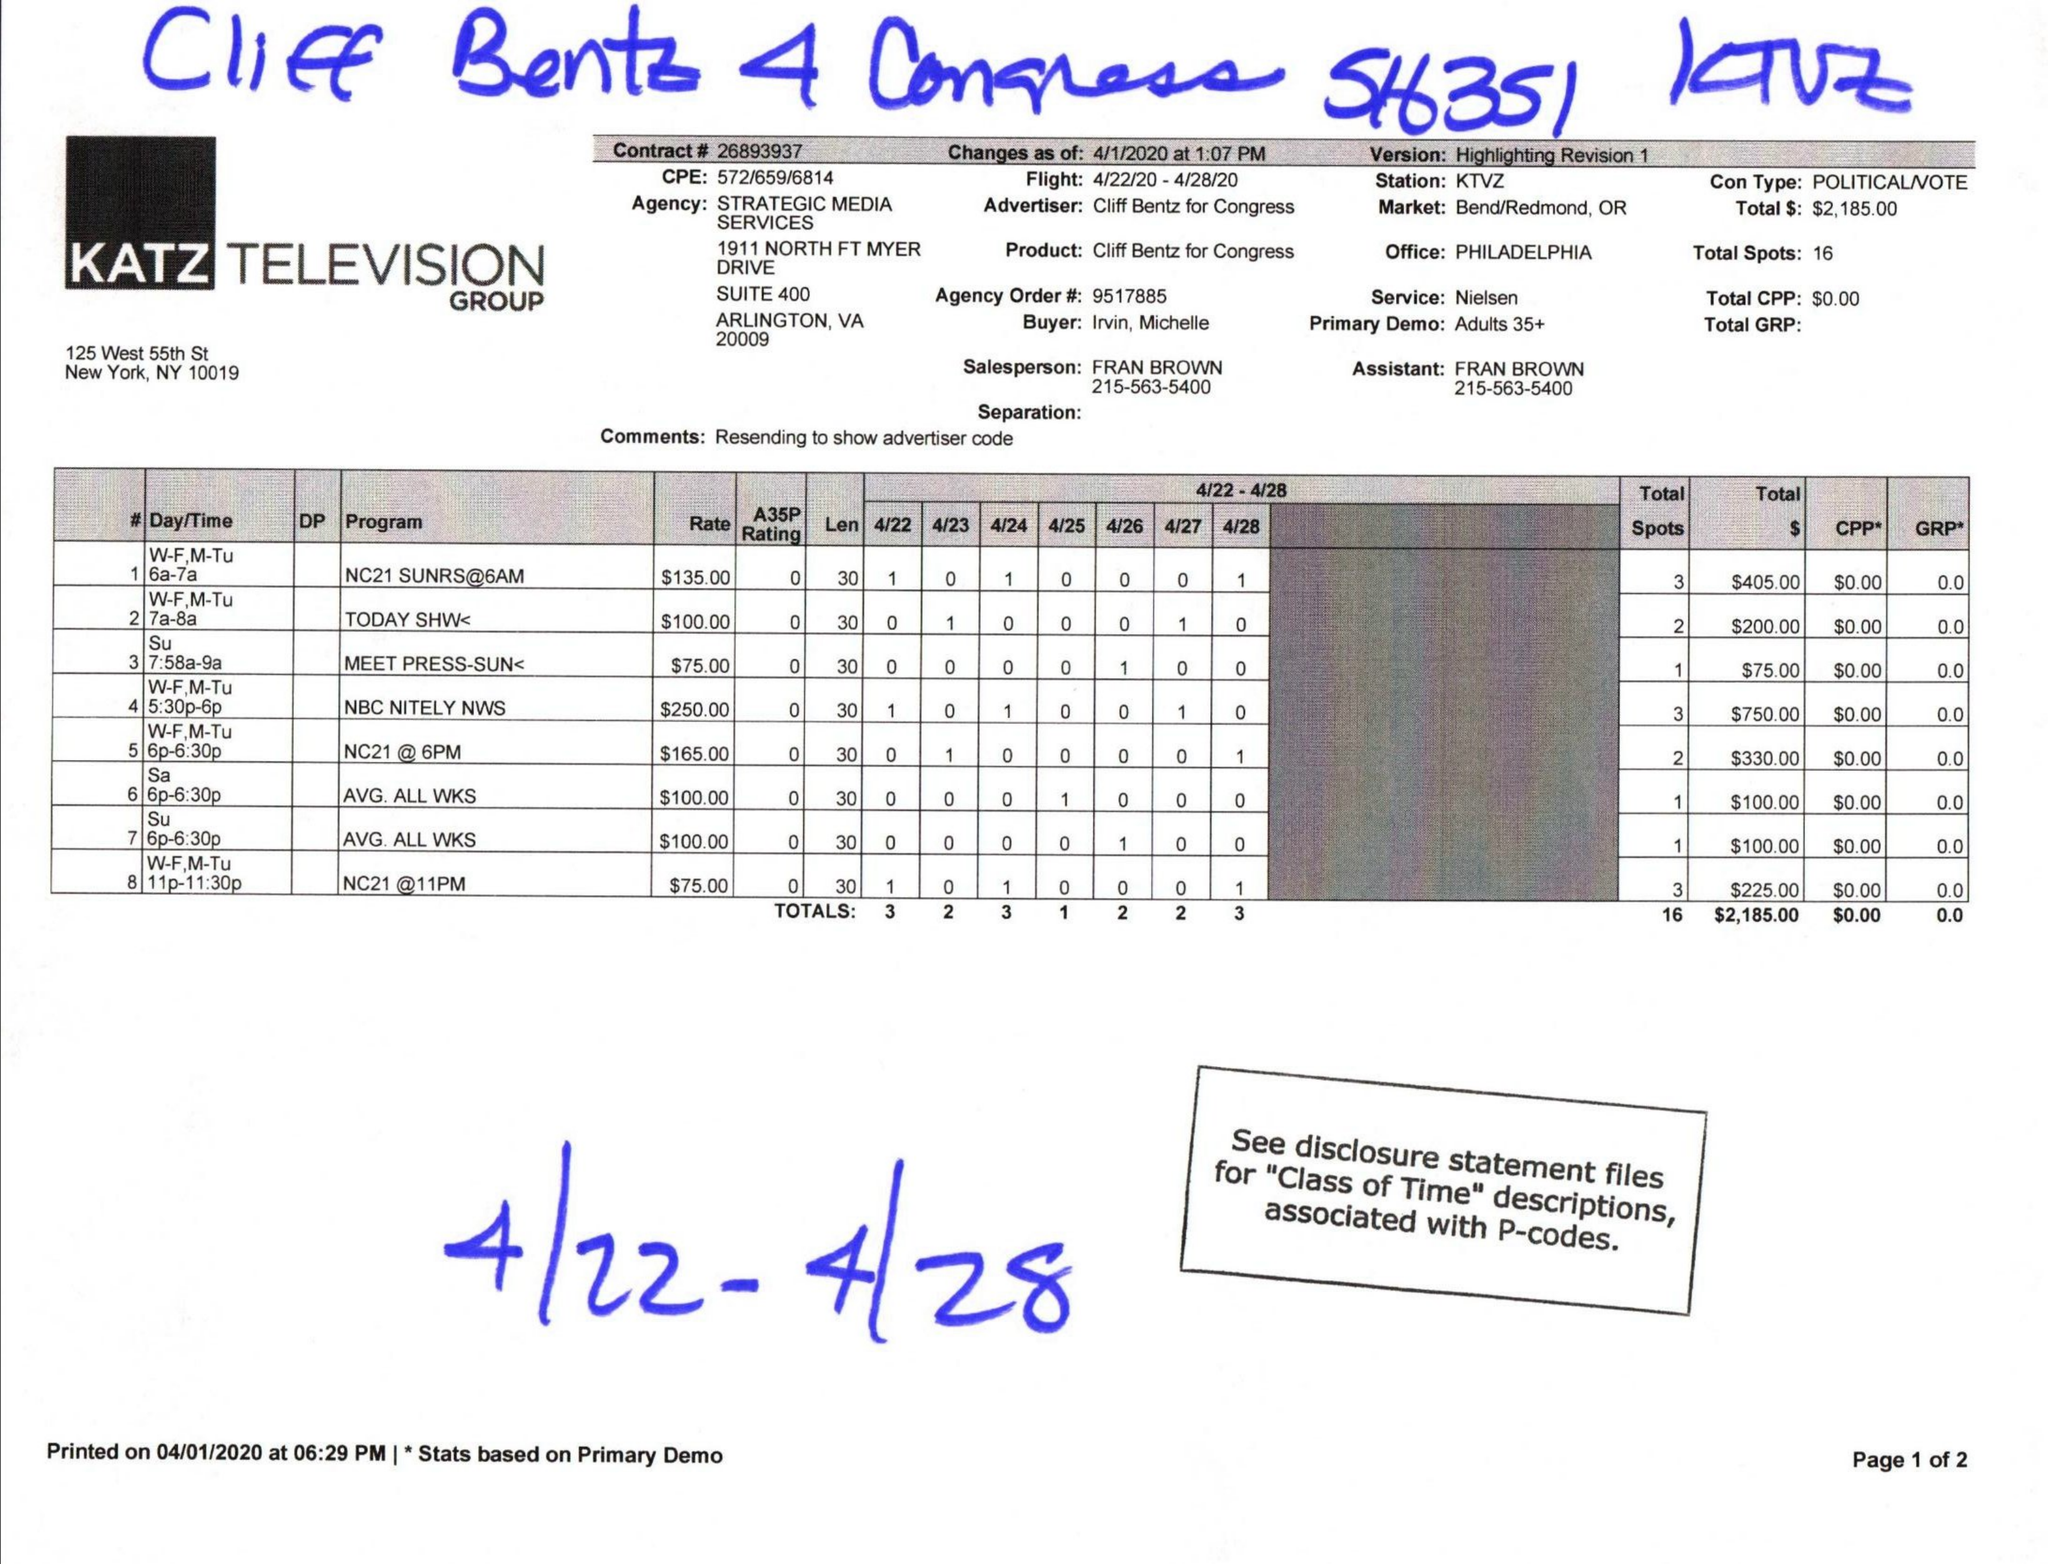What is the value for the flight_from?
Answer the question using a single word or phrase. 04/22/20 